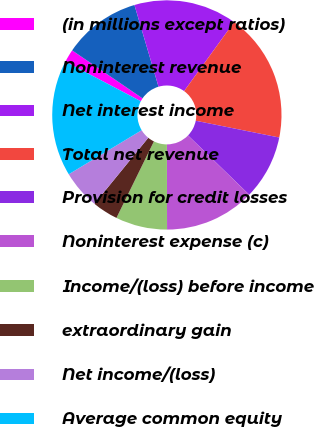<chart> <loc_0><loc_0><loc_500><loc_500><pie_chart><fcel>(in millions except ratios)<fcel>Noninterest revenue<fcel>Net interest income<fcel>Total net revenue<fcel>Provision for credit losses<fcel>Noninterest expense (c)<fcel>Income/(loss) before income<fcel>extraordinary gain<fcel>Net income/(loss)<fcel>Average common equity<nl><fcel>1.82%<fcel>10.91%<fcel>14.54%<fcel>18.18%<fcel>9.09%<fcel>12.73%<fcel>7.27%<fcel>3.64%<fcel>5.46%<fcel>16.36%<nl></chart> 